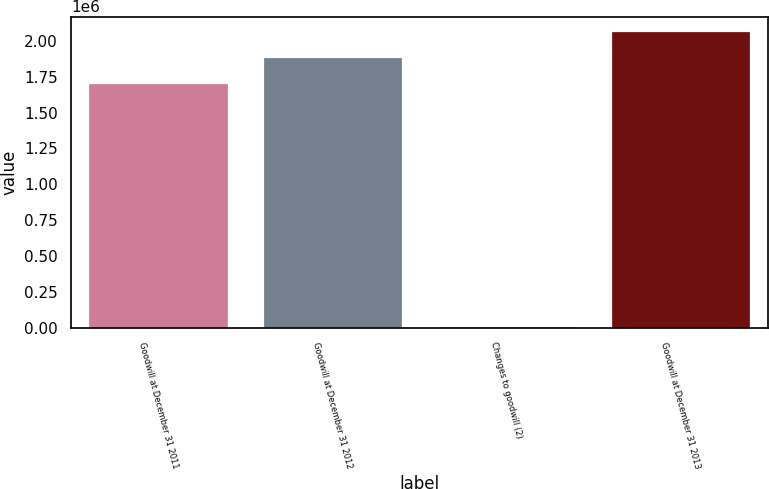<chart> <loc_0><loc_0><loc_500><loc_500><bar_chart><fcel>Goodwill at December 31 2011<fcel>Goodwill at December 31 2012<fcel>Changes to goodwill (2)<fcel>Goodwill at December 31 2013<nl><fcel>1.70858e+06<fcel>1.88708e+06<fcel>13902<fcel>2.06557e+06<nl></chart> 